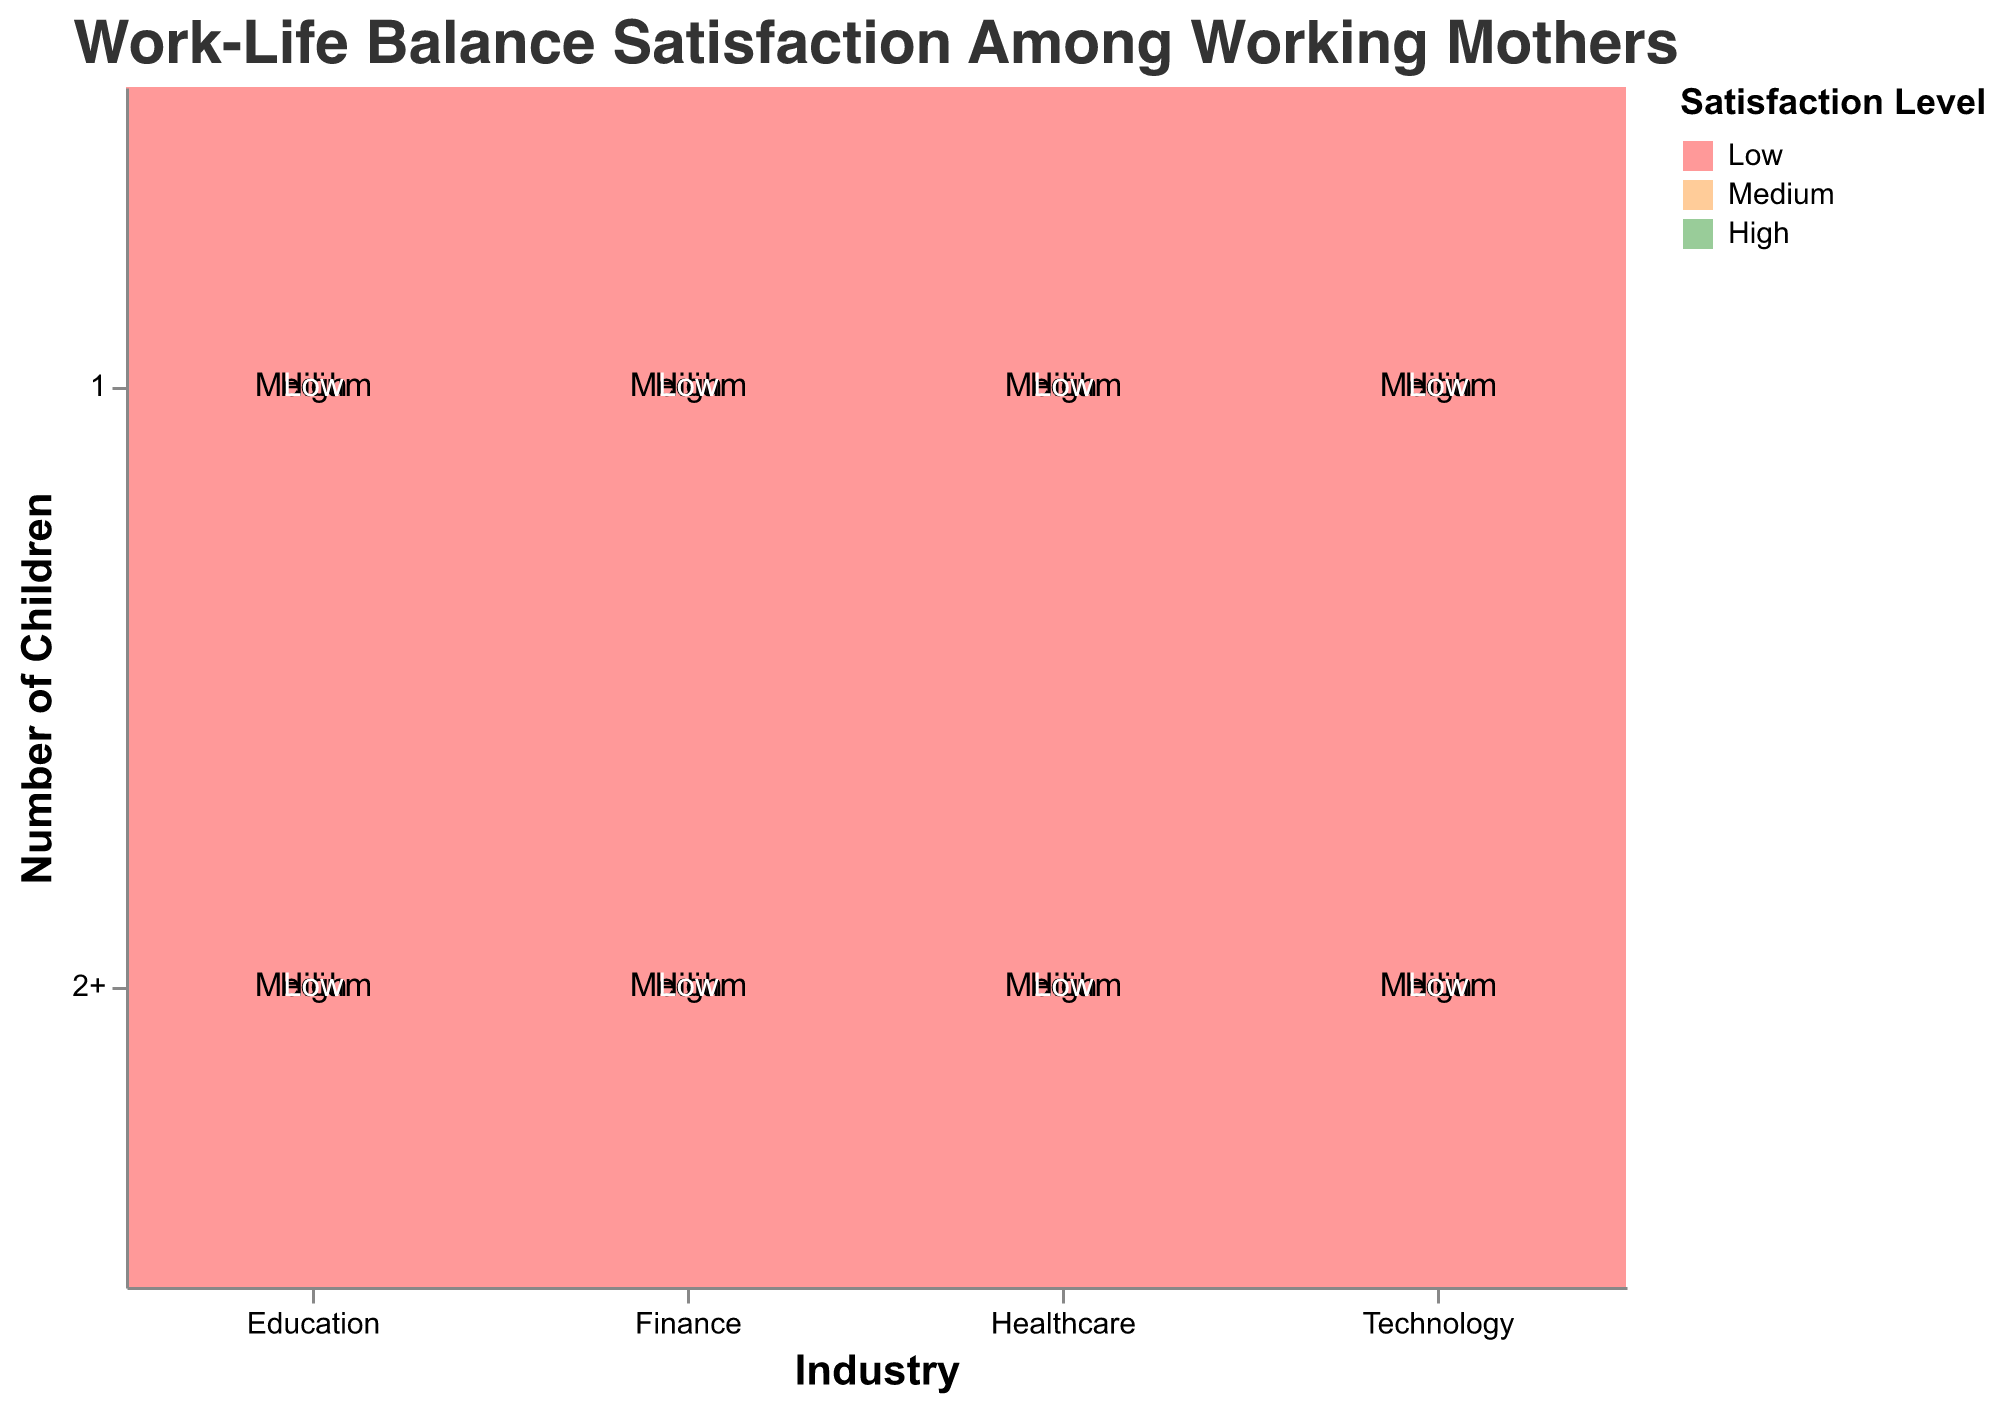What is the overall title of the mosaic plot? The title is typically found at the top of the plot. The main heading provides a summary of what the chart is about, in this case, "Work-Life Balance Satisfaction Among Working Mothers".
Answer: Work-Life Balance Satisfaction Among Working Mothers Which industry has the highest number of mothers with 2 or more children reporting high satisfaction? By examining the mosaic plot, we can observe the rectangles corresponding to different satisfaction levels within each industry, focusing on "2+" children and "High" satisfaction level. "Education" appears to have the largest area for this category.
Answer: Education How does the size of the “High” satisfaction segment for mothers with 1 child in healthcare compare to that for mothers with 1 child in education? Compare the rectangles representing "High" satisfaction for 1 child in both healthcare and education industries. The healthcare rectangle is smaller compared to the education rectangle.
Answer: Education has a larger high satisfaction segment In which industry do mothers with 2 or more children have a higher count of "Low" satisfaction compared to mothers with 1 child? Examine the sizes of the "Low" satisfaction level rectangles for mothers with 2 or more children and mothers with 1 child. In healthcare, the "Low" satisfaction level for mothers with 2 or more children is larger than that for mothers with 1 child.
Answer: Healthcare Which sector has the most significant portion of "Medium" satisfaction among mothers with 1 child? Look at each industry's "Medium" satisfaction segment for mothers with 1 child. Technology has the most significant portion, since its corresponding area is the largest.
Answer: Technology Is the "Medium" satisfaction count higher for mothers with 2 or more children in finance or technology? Compare the sizes of the rectangles for "Medium" satisfaction level in the finance and technology sectors for mothers with 2 or more children. The technology sector's area is larger.
Answer: Technology Which industry shows the least variation in satisfaction levels among mothers with 1 child? Look for the industry that has the most balanced areas corresponding to each satisfaction level among mothers with 1 child. The finance sector appears the most balanced.
Answer: Finance Does the education industry have a higher percentage of high satisfaction for mothers with 1 child compared to those with 2 or more children? Compare the "High" satisfaction level segments for 1 child and 2 or more children within the education sector. The "High" satisfaction is more prominent for mothers with 1 child.
Answer: Yes Which industry has the lowest level of high satisfaction among mothers with 2 or more children? By examining the "High" satisfaction level for mothers with 2 or more children across industries, the finance sector has the smallest area.
Answer: Finance 